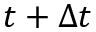<formula> <loc_0><loc_0><loc_500><loc_500>t + \Delta t</formula> 